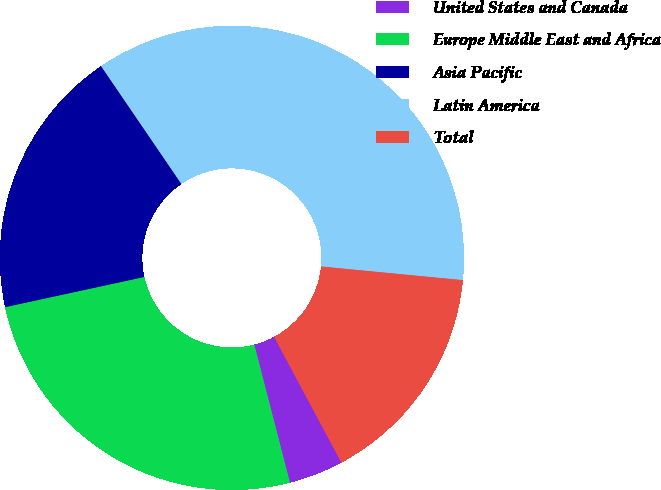Convert chart. <chart><loc_0><loc_0><loc_500><loc_500><pie_chart><fcel>United States and Canada<fcel>Europe Middle East and Africa<fcel>Asia Pacific<fcel>Latin America<fcel>Total<nl><fcel>3.8%<fcel>25.62%<fcel>18.88%<fcel>36.05%<fcel>15.65%<nl></chart> 